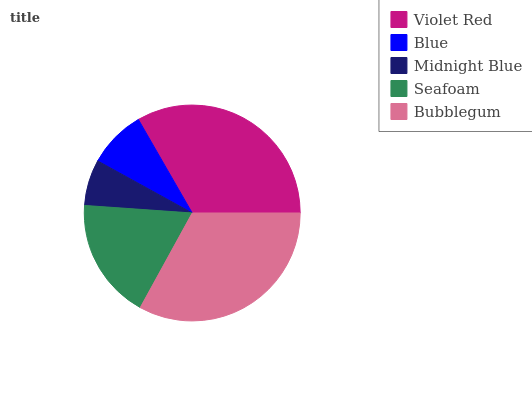Is Midnight Blue the minimum?
Answer yes or no. Yes. Is Violet Red the maximum?
Answer yes or no. Yes. Is Blue the minimum?
Answer yes or no. No. Is Blue the maximum?
Answer yes or no. No. Is Violet Red greater than Blue?
Answer yes or no. Yes. Is Blue less than Violet Red?
Answer yes or no. Yes. Is Blue greater than Violet Red?
Answer yes or no. No. Is Violet Red less than Blue?
Answer yes or no. No. Is Seafoam the high median?
Answer yes or no. Yes. Is Seafoam the low median?
Answer yes or no. Yes. Is Midnight Blue the high median?
Answer yes or no. No. Is Bubblegum the low median?
Answer yes or no. No. 